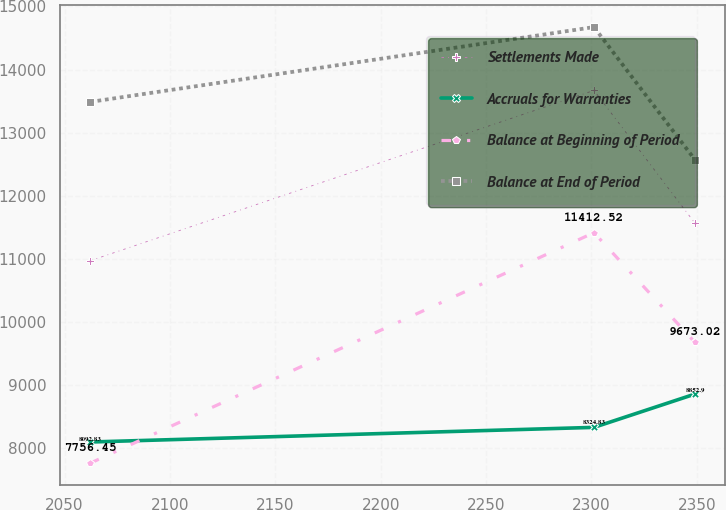<chart> <loc_0><loc_0><loc_500><loc_500><line_chart><ecel><fcel>Settlements Made<fcel>Accruals for Warranties<fcel>Balance at Beginning of Period<fcel>Balance at End of Period<nl><fcel>2062.09<fcel>10966.7<fcel>8092.83<fcel>7756.45<fcel>13485.7<nl><fcel>2301.24<fcel>13668.4<fcel>8324.83<fcel>11412.5<fcel>14672.6<nl><fcel>2349.15<fcel>11563.4<fcel>8852.9<fcel>9673.02<fcel>12569.7<nl></chart> 